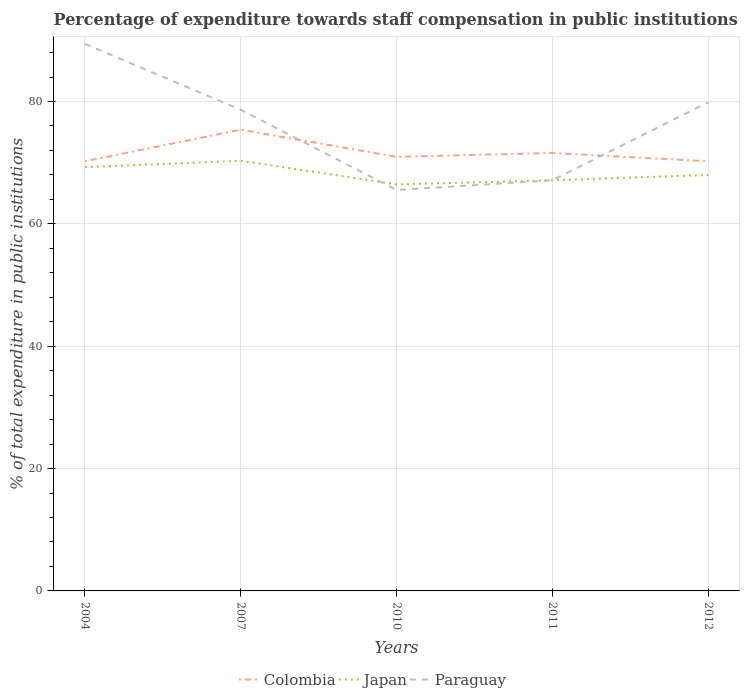Does the line corresponding to Paraguay intersect with the line corresponding to Japan?
Your answer should be very brief. Yes. Is the number of lines equal to the number of legend labels?
Offer a terse response. Yes. Across all years, what is the maximum percentage of expenditure towards staff compensation in Japan?
Your answer should be compact. 66.44. What is the total percentage of expenditure towards staff compensation in Colombia in the graph?
Your answer should be compact. 0. What is the difference between the highest and the second highest percentage of expenditure towards staff compensation in Paraguay?
Keep it short and to the point. 23.89. Is the percentage of expenditure towards staff compensation in Colombia strictly greater than the percentage of expenditure towards staff compensation in Japan over the years?
Offer a very short reply. No. How many years are there in the graph?
Offer a terse response. 5. What is the difference between two consecutive major ticks on the Y-axis?
Your answer should be very brief. 20. Are the values on the major ticks of Y-axis written in scientific E-notation?
Your answer should be compact. No. Does the graph contain any zero values?
Give a very brief answer. No. Does the graph contain grids?
Your answer should be compact. Yes. What is the title of the graph?
Provide a succinct answer. Percentage of expenditure towards staff compensation in public institutions. What is the label or title of the X-axis?
Ensure brevity in your answer.  Years. What is the label or title of the Y-axis?
Provide a succinct answer. % of total expenditure in public institutions. What is the % of total expenditure in public institutions of Colombia in 2004?
Offer a terse response. 70.22. What is the % of total expenditure in public institutions of Japan in 2004?
Your answer should be very brief. 69.26. What is the % of total expenditure in public institutions in Paraguay in 2004?
Your answer should be very brief. 89.41. What is the % of total expenditure in public institutions of Colombia in 2007?
Provide a short and direct response. 75.39. What is the % of total expenditure in public institutions in Japan in 2007?
Offer a terse response. 70.31. What is the % of total expenditure in public institutions in Paraguay in 2007?
Provide a succinct answer. 78.65. What is the % of total expenditure in public institutions in Colombia in 2010?
Your answer should be very brief. 70.95. What is the % of total expenditure in public institutions in Japan in 2010?
Your answer should be compact. 66.44. What is the % of total expenditure in public institutions in Paraguay in 2010?
Ensure brevity in your answer.  65.53. What is the % of total expenditure in public institutions in Colombia in 2011?
Offer a very short reply. 71.58. What is the % of total expenditure in public institutions in Japan in 2011?
Make the answer very short. 67.12. What is the % of total expenditure in public institutions of Paraguay in 2011?
Offer a terse response. 67.13. What is the % of total expenditure in public institutions of Colombia in 2012?
Give a very brief answer. 70.22. What is the % of total expenditure in public institutions in Japan in 2012?
Your response must be concise. 68. What is the % of total expenditure in public institutions of Paraguay in 2012?
Offer a terse response. 79.88. Across all years, what is the maximum % of total expenditure in public institutions in Colombia?
Provide a short and direct response. 75.39. Across all years, what is the maximum % of total expenditure in public institutions in Japan?
Make the answer very short. 70.31. Across all years, what is the maximum % of total expenditure in public institutions in Paraguay?
Provide a succinct answer. 89.41. Across all years, what is the minimum % of total expenditure in public institutions of Colombia?
Your answer should be compact. 70.22. Across all years, what is the minimum % of total expenditure in public institutions of Japan?
Provide a succinct answer. 66.44. Across all years, what is the minimum % of total expenditure in public institutions of Paraguay?
Your answer should be compact. 65.53. What is the total % of total expenditure in public institutions in Colombia in the graph?
Keep it short and to the point. 358.37. What is the total % of total expenditure in public institutions in Japan in the graph?
Make the answer very short. 341.14. What is the total % of total expenditure in public institutions in Paraguay in the graph?
Keep it short and to the point. 380.6. What is the difference between the % of total expenditure in public institutions of Colombia in 2004 and that in 2007?
Make the answer very short. -5.17. What is the difference between the % of total expenditure in public institutions in Japan in 2004 and that in 2007?
Your answer should be compact. -1.05. What is the difference between the % of total expenditure in public institutions in Paraguay in 2004 and that in 2007?
Give a very brief answer. 10.76. What is the difference between the % of total expenditure in public institutions in Colombia in 2004 and that in 2010?
Your answer should be compact. -0.73. What is the difference between the % of total expenditure in public institutions of Japan in 2004 and that in 2010?
Offer a very short reply. 2.82. What is the difference between the % of total expenditure in public institutions of Paraguay in 2004 and that in 2010?
Your response must be concise. 23.89. What is the difference between the % of total expenditure in public institutions of Colombia in 2004 and that in 2011?
Your answer should be compact. -1.36. What is the difference between the % of total expenditure in public institutions in Japan in 2004 and that in 2011?
Your response must be concise. 2.14. What is the difference between the % of total expenditure in public institutions of Paraguay in 2004 and that in 2011?
Your answer should be very brief. 22.29. What is the difference between the % of total expenditure in public institutions in Colombia in 2004 and that in 2012?
Your answer should be very brief. 0. What is the difference between the % of total expenditure in public institutions of Japan in 2004 and that in 2012?
Keep it short and to the point. 1.27. What is the difference between the % of total expenditure in public institutions of Paraguay in 2004 and that in 2012?
Give a very brief answer. 9.53. What is the difference between the % of total expenditure in public institutions in Colombia in 2007 and that in 2010?
Offer a very short reply. 4.44. What is the difference between the % of total expenditure in public institutions in Japan in 2007 and that in 2010?
Keep it short and to the point. 3.87. What is the difference between the % of total expenditure in public institutions in Paraguay in 2007 and that in 2010?
Offer a terse response. 13.12. What is the difference between the % of total expenditure in public institutions of Colombia in 2007 and that in 2011?
Your answer should be very brief. 3.81. What is the difference between the % of total expenditure in public institutions in Japan in 2007 and that in 2011?
Offer a terse response. 3.19. What is the difference between the % of total expenditure in public institutions of Paraguay in 2007 and that in 2011?
Ensure brevity in your answer.  11.52. What is the difference between the % of total expenditure in public institutions in Colombia in 2007 and that in 2012?
Your answer should be very brief. 5.17. What is the difference between the % of total expenditure in public institutions in Japan in 2007 and that in 2012?
Offer a terse response. 2.32. What is the difference between the % of total expenditure in public institutions of Paraguay in 2007 and that in 2012?
Provide a short and direct response. -1.23. What is the difference between the % of total expenditure in public institutions in Colombia in 2010 and that in 2011?
Provide a succinct answer. -0.63. What is the difference between the % of total expenditure in public institutions of Japan in 2010 and that in 2011?
Offer a terse response. -0.67. What is the difference between the % of total expenditure in public institutions in Paraguay in 2010 and that in 2011?
Your response must be concise. -1.6. What is the difference between the % of total expenditure in public institutions in Colombia in 2010 and that in 2012?
Ensure brevity in your answer.  0.73. What is the difference between the % of total expenditure in public institutions in Japan in 2010 and that in 2012?
Make the answer very short. -1.55. What is the difference between the % of total expenditure in public institutions of Paraguay in 2010 and that in 2012?
Ensure brevity in your answer.  -14.36. What is the difference between the % of total expenditure in public institutions of Colombia in 2011 and that in 2012?
Offer a very short reply. 1.36. What is the difference between the % of total expenditure in public institutions in Japan in 2011 and that in 2012?
Give a very brief answer. -0.88. What is the difference between the % of total expenditure in public institutions in Paraguay in 2011 and that in 2012?
Keep it short and to the point. -12.75. What is the difference between the % of total expenditure in public institutions of Colombia in 2004 and the % of total expenditure in public institutions of Japan in 2007?
Your response must be concise. -0.09. What is the difference between the % of total expenditure in public institutions in Colombia in 2004 and the % of total expenditure in public institutions in Paraguay in 2007?
Keep it short and to the point. -8.43. What is the difference between the % of total expenditure in public institutions of Japan in 2004 and the % of total expenditure in public institutions of Paraguay in 2007?
Your answer should be compact. -9.39. What is the difference between the % of total expenditure in public institutions in Colombia in 2004 and the % of total expenditure in public institutions in Japan in 2010?
Provide a short and direct response. 3.78. What is the difference between the % of total expenditure in public institutions in Colombia in 2004 and the % of total expenditure in public institutions in Paraguay in 2010?
Give a very brief answer. 4.7. What is the difference between the % of total expenditure in public institutions of Japan in 2004 and the % of total expenditure in public institutions of Paraguay in 2010?
Keep it short and to the point. 3.74. What is the difference between the % of total expenditure in public institutions of Colombia in 2004 and the % of total expenditure in public institutions of Japan in 2011?
Provide a short and direct response. 3.1. What is the difference between the % of total expenditure in public institutions in Colombia in 2004 and the % of total expenditure in public institutions in Paraguay in 2011?
Ensure brevity in your answer.  3.09. What is the difference between the % of total expenditure in public institutions of Japan in 2004 and the % of total expenditure in public institutions of Paraguay in 2011?
Offer a very short reply. 2.13. What is the difference between the % of total expenditure in public institutions of Colombia in 2004 and the % of total expenditure in public institutions of Japan in 2012?
Make the answer very short. 2.23. What is the difference between the % of total expenditure in public institutions of Colombia in 2004 and the % of total expenditure in public institutions of Paraguay in 2012?
Provide a short and direct response. -9.66. What is the difference between the % of total expenditure in public institutions of Japan in 2004 and the % of total expenditure in public institutions of Paraguay in 2012?
Offer a terse response. -10.62. What is the difference between the % of total expenditure in public institutions of Colombia in 2007 and the % of total expenditure in public institutions of Japan in 2010?
Provide a short and direct response. 8.95. What is the difference between the % of total expenditure in public institutions in Colombia in 2007 and the % of total expenditure in public institutions in Paraguay in 2010?
Keep it short and to the point. 9.86. What is the difference between the % of total expenditure in public institutions in Japan in 2007 and the % of total expenditure in public institutions in Paraguay in 2010?
Keep it short and to the point. 4.79. What is the difference between the % of total expenditure in public institutions in Colombia in 2007 and the % of total expenditure in public institutions in Japan in 2011?
Offer a very short reply. 8.27. What is the difference between the % of total expenditure in public institutions of Colombia in 2007 and the % of total expenditure in public institutions of Paraguay in 2011?
Make the answer very short. 8.26. What is the difference between the % of total expenditure in public institutions in Japan in 2007 and the % of total expenditure in public institutions in Paraguay in 2011?
Your response must be concise. 3.18. What is the difference between the % of total expenditure in public institutions of Colombia in 2007 and the % of total expenditure in public institutions of Japan in 2012?
Your response must be concise. 7.4. What is the difference between the % of total expenditure in public institutions in Colombia in 2007 and the % of total expenditure in public institutions in Paraguay in 2012?
Keep it short and to the point. -4.49. What is the difference between the % of total expenditure in public institutions of Japan in 2007 and the % of total expenditure in public institutions of Paraguay in 2012?
Keep it short and to the point. -9.57. What is the difference between the % of total expenditure in public institutions of Colombia in 2010 and the % of total expenditure in public institutions of Japan in 2011?
Offer a very short reply. 3.83. What is the difference between the % of total expenditure in public institutions of Colombia in 2010 and the % of total expenditure in public institutions of Paraguay in 2011?
Your answer should be compact. 3.82. What is the difference between the % of total expenditure in public institutions of Japan in 2010 and the % of total expenditure in public institutions of Paraguay in 2011?
Keep it short and to the point. -0.68. What is the difference between the % of total expenditure in public institutions of Colombia in 2010 and the % of total expenditure in public institutions of Japan in 2012?
Your answer should be very brief. 2.96. What is the difference between the % of total expenditure in public institutions in Colombia in 2010 and the % of total expenditure in public institutions in Paraguay in 2012?
Offer a terse response. -8.93. What is the difference between the % of total expenditure in public institutions of Japan in 2010 and the % of total expenditure in public institutions of Paraguay in 2012?
Provide a succinct answer. -13.44. What is the difference between the % of total expenditure in public institutions of Colombia in 2011 and the % of total expenditure in public institutions of Japan in 2012?
Make the answer very short. 3.59. What is the difference between the % of total expenditure in public institutions in Colombia in 2011 and the % of total expenditure in public institutions in Paraguay in 2012?
Give a very brief answer. -8.3. What is the difference between the % of total expenditure in public institutions of Japan in 2011 and the % of total expenditure in public institutions of Paraguay in 2012?
Provide a succinct answer. -12.76. What is the average % of total expenditure in public institutions in Colombia per year?
Your response must be concise. 71.67. What is the average % of total expenditure in public institutions of Japan per year?
Keep it short and to the point. 68.23. What is the average % of total expenditure in public institutions of Paraguay per year?
Make the answer very short. 76.12. In the year 2004, what is the difference between the % of total expenditure in public institutions of Colombia and % of total expenditure in public institutions of Japan?
Your answer should be compact. 0.96. In the year 2004, what is the difference between the % of total expenditure in public institutions in Colombia and % of total expenditure in public institutions in Paraguay?
Give a very brief answer. -19.19. In the year 2004, what is the difference between the % of total expenditure in public institutions of Japan and % of total expenditure in public institutions of Paraguay?
Provide a succinct answer. -20.15. In the year 2007, what is the difference between the % of total expenditure in public institutions in Colombia and % of total expenditure in public institutions in Japan?
Provide a short and direct response. 5.08. In the year 2007, what is the difference between the % of total expenditure in public institutions in Colombia and % of total expenditure in public institutions in Paraguay?
Offer a very short reply. -3.26. In the year 2007, what is the difference between the % of total expenditure in public institutions in Japan and % of total expenditure in public institutions in Paraguay?
Your answer should be very brief. -8.34. In the year 2010, what is the difference between the % of total expenditure in public institutions of Colombia and % of total expenditure in public institutions of Japan?
Your response must be concise. 4.51. In the year 2010, what is the difference between the % of total expenditure in public institutions in Colombia and % of total expenditure in public institutions in Paraguay?
Make the answer very short. 5.43. In the year 2010, what is the difference between the % of total expenditure in public institutions in Japan and % of total expenditure in public institutions in Paraguay?
Offer a very short reply. 0.92. In the year 2011, what is the difference between the % of total expenditure in public institutions in Colombia and % of total expenditure in public institutions in Japan?
Your answer should be compact. 4.46. In the year 2011, what is the difference between the % of total expenditure in public institutions of Colombia and % of total expenditure in public institutions of Paraguay?
Offer a terse response. 4.45. In the year 2011, what is the difference between the % of total expenditure in public institutions of Japan and % of total expenditure in public institutions of Paraguay?
Give a very brief answer. -0.01. In the year 2012, what is the difference between the % of total expenditure in public institutions of Colombia and % of total expenditure in public institutions of Japan?
Make the answer very short. 2.22. In the year 2012, what is the difference between the % of total expenditure in public institutions in Colombia and % of total expenditure in public institutions in Paraguay?
Give a very brief answer. -9.66. In the year 2012, what is the difference between the % of total expenditure in public institutions of Japan and % of total expenditure in public institutions of Paraguay?
Provide a succinct answer. -11.89. What is the ratio of the % of total expenditure in public institutions in Colombia in 2004 to that in 2007?
Provide a succinct answer. 0.93. What is the ratio of the % of total expenditure in public institutions of Japan in 2004 to that in 2007?
Ensure brevity in your answer.  0.99. What is the ratio of the % of total expenditure in public institutions of Paraguay in 2004 to that in 2007?
Offer a very short reply. 1.14. What is the ratio of the % of total expenditure in public institutions of Colombia in 2004 to that in 2010?
Make the answer very short. 0.99. What is the ratio of the % of total expenditure in public institutions in Japan in 2004 to that in 2010?
Keep it short and to the point. 1.04. What is the ratio of the % of total expenditure in public institutions of Paraguay in 2004 to that in 2010?
Your answer should be very brief. 1.36. What is the ratio of the % of total expenditure in public institutions in Colombia in 2004 to that in 2011?
Your answer should be compact. 0.98. What is the ratio of the % of total expenditure in public institutions in Japan in 2004 to that in 2011?
Keep it short and to the point. 1.03. What is the ratio of the % of total expenditure in public institutions of Paraguay in 2004 to that in 2011?
Ensure brevity in your answer.  1.33. What is the ratio of the % of total expenditure in public institutions in Japan in 2004 to that in 2012?
Make the answer very short. 1.02. What is the ratio of the % of total expenditure in public institutions of Paraguay in 2004 to that in 2012?
Keep it short and to the point. 1.12. What is the ratio of the % of total expenditure in public institutions of Colombia in 2007 to that in 2010?
Provide a succinct answer. 1.06. What is the ratio of the % of total expenditure in public institutions of Japan in 2007 to that in 2010?
Offer a very short reply. 1.06. What is the ratio of the % of total expenditure in public institutions in Paraguay in 2007 to that in 2010?
Provide a succinct answer. 1.2. What is the ratio of the % of total expenditure in public institutions of Colombia in 2007 to that in 2011?
Offer a terse response. 1.05. What is the ratio of the % of total expenditure in public institutions of Japan in 2007 to that in 2011?
Provide a succinct answer. 1.05. What is the ratio of the % of total expenditure in public institutions of Paraguay in 2007 to that in 2011?
Ensure brevity in your answer.  1.17. What is the ratio of the % of total expenditure in public institutions of Colombia in 2007 to that in 2012?
Provide a succinct answer. 1.07. What is the ratio of the % of total expenditure in public institutions in Japan in 2007 to that in 2012?
Keep it short and to the point. 1.03. What is the ratio of the % of total expenditure in public institutions in Paraguay in 2007 to that in 2012?
Keep it short and to the point. 0.98. What is the ratio of the % of total expenditure in public institutions in Colombia in 2010 to that in 2011?
Provide a short and direct response. 0.99. What is the ratio of the % of total expenditure in public institutions in Japan in 2010 to that in 2011?
Provide a succinct answer. 0.99. What is the ratio of the % of total expenditure in public institutions of Paraguay in 2010 to that in 2011?
Your answer should be compact. 0.98. What is the ratio of the % of total expenditure in public institutions of Colombia in 2010 to that in 2012?
Ensure brevity in your answer.  1.01. What is the ratio of the % of total expenditure in public institutions in Japan in 2010 to that in 2012?
Give a very brief answer. 0.98. What is the ratio of the % of total expenditure in public institutions of Paraguay in 2010 to that in 2012?
Offer a terse response. 0.82. What is the ratio of the % of total expenditure in public institutions of Colombia in 2011 to that in 2012?
Your answer should be very brief. 1.02. What is the ratio of the % of total expenditure in public institutions in Japan in 2011 to that in 2012?
Provide a succinct answer. 0.99. What is the ratio of the % of total expenditure in public institutions of Paraguay in 2011 to that in 2012?
Give a very brief answer. 0.84. What is the difference between the highest and the second highest % of total expenditure in public institutions in Colombia?
Provide a succinct answer. 3.81. What is the difference between the highest and the second highest % of total expenditure in public institutions of Japan?
Ensure brevity in your answer.  1.05. What is the difference between the highest and the second highest % of total expenditure in public institutions of Paraguay?
Offer a terse response. 9.53. What is the difference between the highest and the lowest % of total expenditure in public institutions in Colombia?
Offer a terse response. 5.17. What is the difference between the highest and the lowest % of total expenditure in public institutions of Japan?
Provide a short and direct response. 3.87. What is the difference between the highest and the lowest % of total expenditure in public institutions in Paraguay?
Provide a short and direct response. 23.89. 